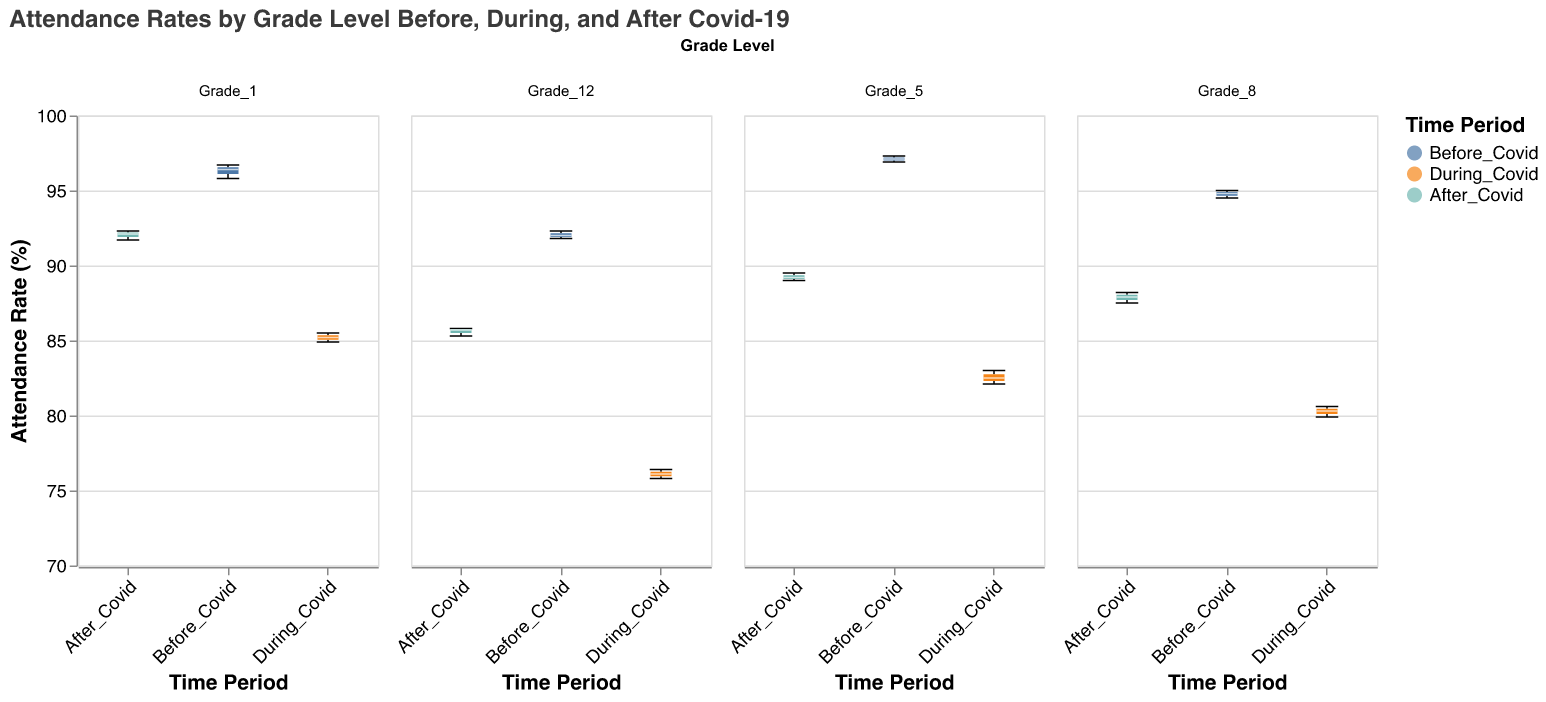Which grade had the highest attendance rates before Covid-19? Grade 5 had the highest attendance rates before Covid-19. This can be seen by observing the box plot for Grade 5 in the "Before_Covid" period, which is higher than the other grades.
Answer: Grade 5 How did Grade 12 attendance rates change from during Covid-19 to after Covid-19? To see the change, compare the box plots for Grade 12 during and after Covid-19. The attendance rates increased from around 76 to around 85 after Covid-19.
Answer: Increased What was the median attendance rate for Grade 1 during Covid-19? The median value is indicated by a white line inside the box plot for Grade 1 during the Covid-19 period, which is around 85.
Answer: 85 Did any grade level have an attendance rate drop of at least 15% from before Covid-19 to during Covid-19? By comparing the box plots before and during Covid-19 for each grade, Grade 12 shows a decrease from about 92 to around 76, which is a drop of more than 15%.
Answer: Yes, Grade 12 Which grade level had the most significant improvement in attendance rates after Covid-19 compared to during Covid-19? Compare the height difference between the box plots during and after Covid-19. Grade 12 shows the most significant increase from around 76 to about 85, indicating the largest improvement.
Answer: Grade 12 What was the range of attendance rates for Grade 8 before Covid-19? The range is the difference between the maximum and minimum values in the box plot for Grade 8 before Covid-19. The values range from approximately 94.5 to 95.0.
Answer: 0.5 How did the attendance rates of Grade 5 during Covid-19 compare to those of Grade 1 after Covid-19? Compare the box plots of Grade 5 during Covid-19 and Grade 1 after Covid-19. Grade 5 has attendance rates around 82, whereas Grade 1 has rates around 92.
Answer: Grade 1 had higher rates What is the attendance rate trend for Grade 8 from before Covid-19 to after Covid-19? Observe the median points in the box plots for Grade 8 across the periods. The attendance starts at around 94.8 before Covid-19, drops to about 80.3 during Covid-19, and recovers to approximately 87.5 after Covid-19.
Answer: Initial drop, then increase Which grade had the smallest drop in attendance rates during Covid-19 compared to before Covid-19? By comparing the drops across grades, Grade 1 had the smallest drop, from around 96.4 to about 85 during Covid-19.
Answer: Grade 1 